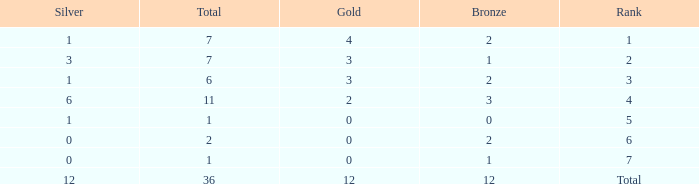What is the largest total for a team with fewer than 12 bronze, 1 silver and 0 gold medals? 1.0. 